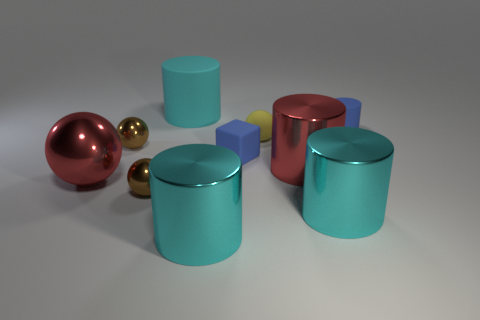There is a blue rubber object behind the brown metal sphere that is behind the large sphere; what is its size? The blue rubber object positioned behind the brown metal sphere, which in turn is behind the large, central sphere, appears to be relatively small in comparison to the other objects in the image. 